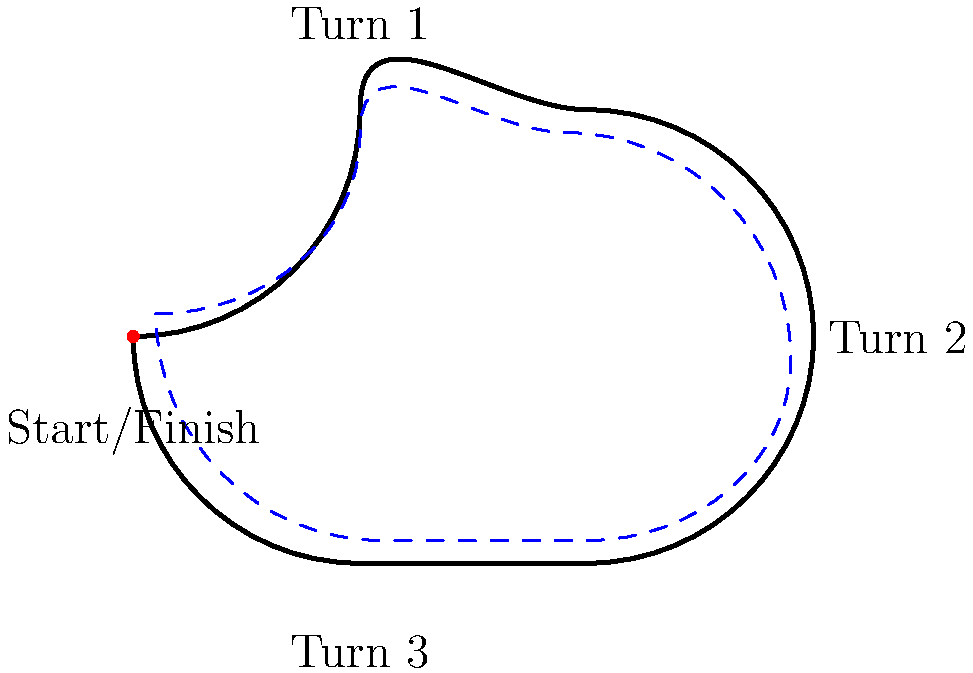In the track layout diagram above, the blue dashed line represents the racing line. Why does the racing line appear to cut the corner in Turn 1 instead of following the track's outer edge? To understand why the racing line cuts the corner in Turn 1, let's break it down step-by-step:

1. Purpose of the racing line: The racing line is the fastest way around a track, optimizing speed and minimizing lap time.

2. Straightening the curve: By cutting the corner, drivers can straighten out the curve, allowing them to maintain higher speeds through the turn.

3. Wider radius: Cutting the corner creates a wider radius through the turn, which reduces the centrifugal force acting on the car. This allows for higher cornering speeds.

4. Late apex: The racing line typically approaches what's called a "late apex," where the car reaches the inside of the corner later than the geometric center of the turn. This allows for earlier acceleration out of the corner.

5. Entry speed vs. exit speed: While cutting the corner may slightly reduce entry speed, it significantly increases exit speed. In racing, a higher exit speed is generally more advantageous as it carries onto the following straight.

6. Balancing grip: By taking a wider entry, drivers can balance the car's grip between cornering and acceleration, maximizing overall performance through the turn.

7. Setting up for the next turn: The racing line through one corner often considers the optimal entry for the next corner, creating a flowing line through multiple turns.

This approach to cornering is a fundamental technique in motor racing, allowing drivers like Parker Thompson to extract maximum performance from their vehicles.
Answer: To maximize speed and minimize lap time by optimizing corner radius and exit speed. 